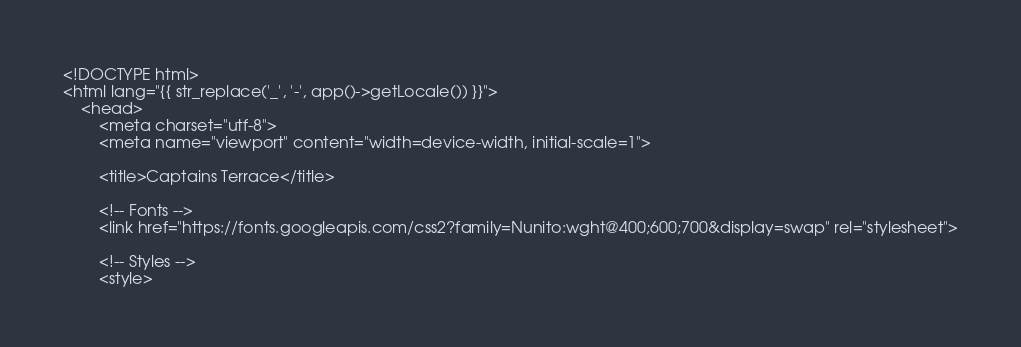Convert code to text. <code><loc_0><loc_0><loc_500><loc_500><_PHP_><!DOCTYPE html>
<html lang="{{ str_replace('_', '-', app()->getLocale()) }}">
    <head>
        <meta charset="utf-8">
        <meta name="viewport" content="width=device-width, initial-scale=1">

        <title>Captains Terrace</title>

        <!-- Fonts -->
        <link href="https://fonts.googleapis.com/css2?family=Nunito:wght@400;600;700&display=swap" rel="stylesheet">

        <!-- Styles -->
        <style></code> 